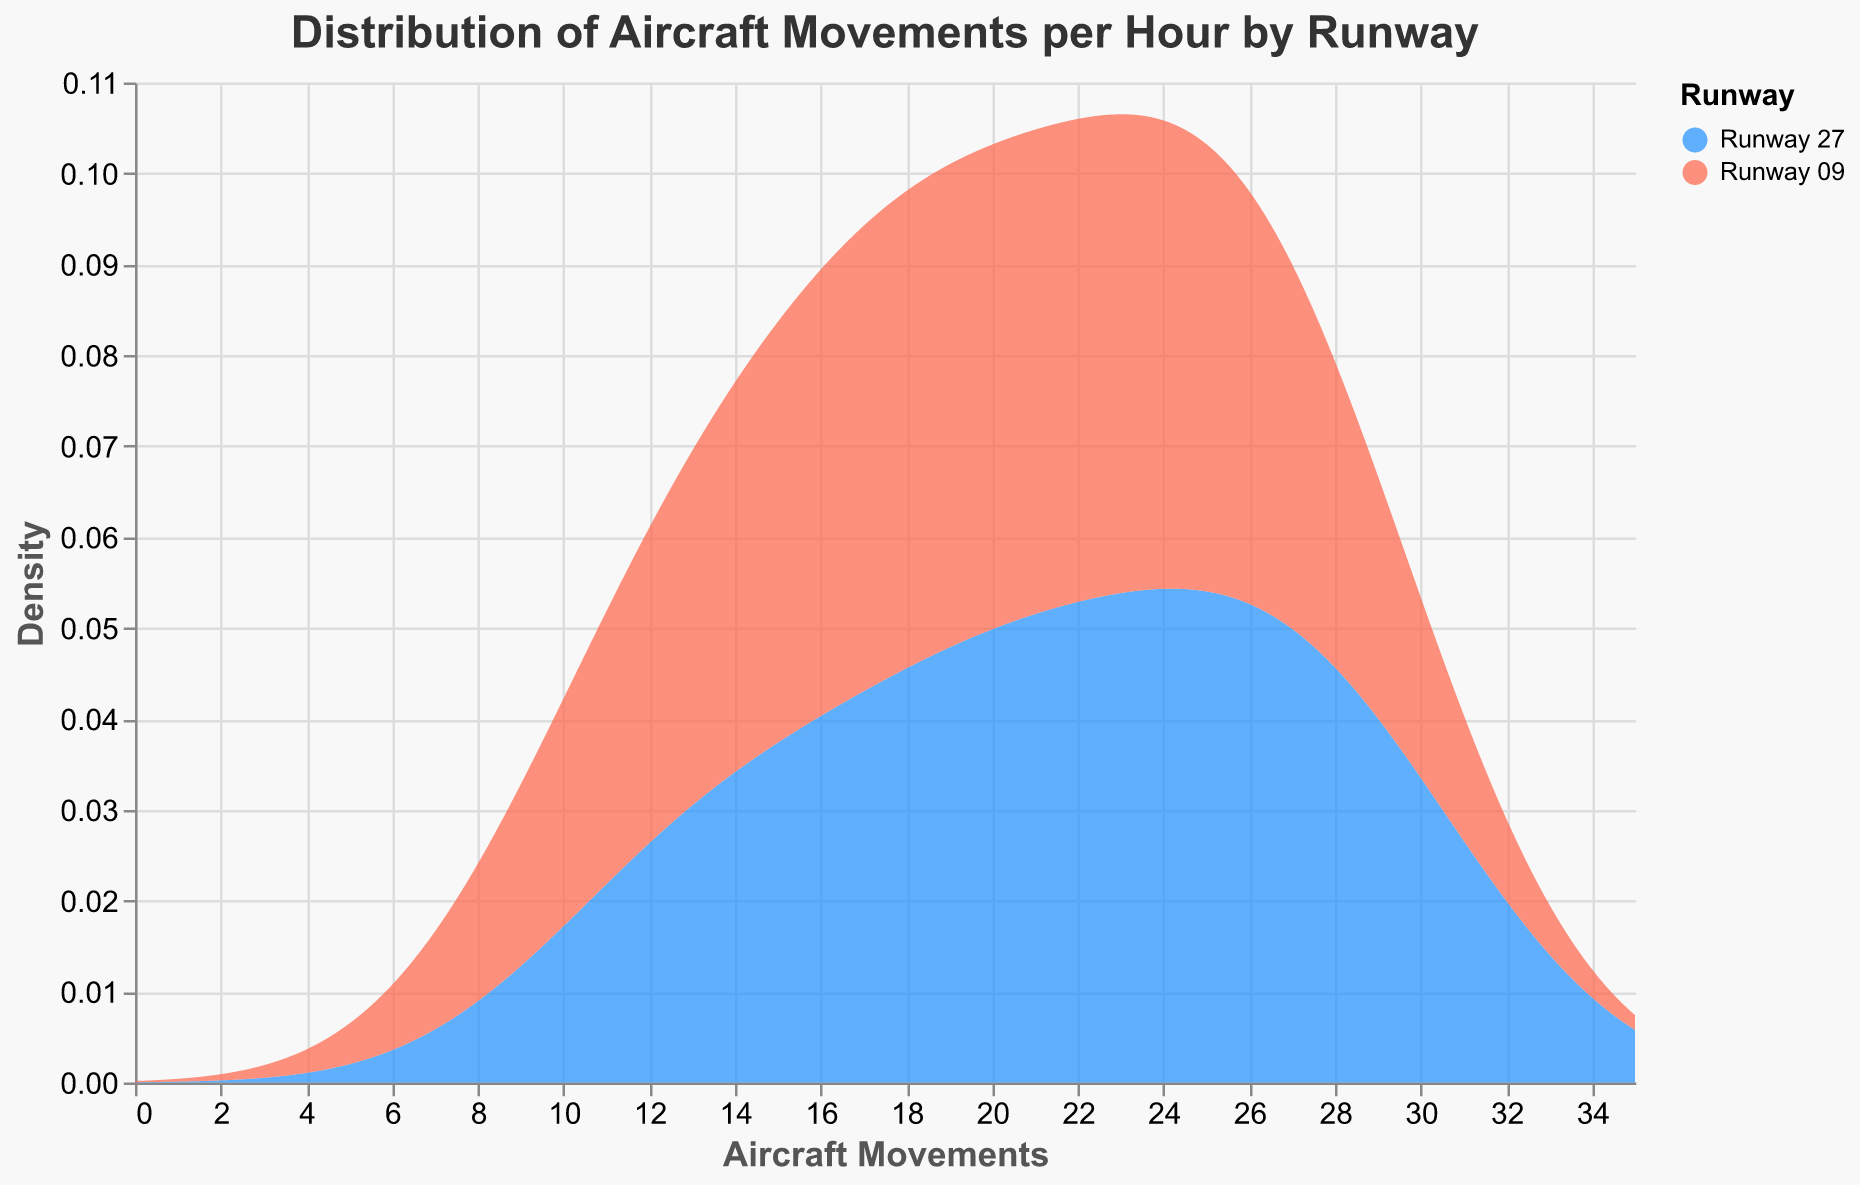What is the title of the figure? The title is the text displayed prominently at the top of the figure, and it communicates the main message or focus of the chart. The title in this figure is "Distribution of Aircraft Movements per Hour by Runway".
Answer: Distribution of Aircraft Movements per Hour by Runway Which color represents 'Runway 27'? The colors representing different elements are shown in the legend. According to the legend, 'Runway 27' is represented by the blue color.
Answer: Blue What is the x-axis title and its font size? The x-axis title is labeled as "Aircraft Movements", and the font size for the title is noted in the axis configuration details as 14.
Answer: Aircraft Movements, 14 Which runway has the higher peak density in aircraft movements according to the figure? By comparing the density peaks of both distribution plots, it is evident that the peak density for 'Runway 27' is higher than that of 'Runway 09'.
Answer: Runway 27 At approximately what aircraft movement count do both runways show notable density peaks? By observing the x-axis and the density peaks of both runways, it is noticeable that both runways have density peaks at the vicinity of 25 aircraft movements.
Answer: Around 25 aircraft movements What is the color representation for 'Runway 09' and its specific hue shade? In the legend on the figure, 'Runway 09' is assigned the red color. This information is seen from the color scheme of the legend entries.
Answer: Red What is the range of the x-axis in the figure, and what does this represent? The x-axis range in the figure spans from 0 to 35, representing the possible number of aircraft movements. This is determined from the extent of the x-axis marked in the chart.
Answer: 0 to 35 Which hour shows the highest aircraft movements for 'Runway 27'? Based on the data, the hour with the highest recorded aircraft movements for 'Runway 27' is the hour with a count of 30 movements, which happens at 14:00. This highlights the peak operational period on that runway.
Answer: 14:00 How can you interpret the overall aircraft movement trends for both runways based on the density plots? Observing the density plots, 'Runway 27' and 'Runway 09' both show increasing aircraft movements during the day with 'Runway 27' showing consistently higher movements. Both runways peak around similar movement counts, though the densities indicate more frequent high movement counts on 'Runway 27'. This reasoning is derived from the visual density analysis.
Answer: 'Runway 27' has higher movements overall; both peak near 25 movements 